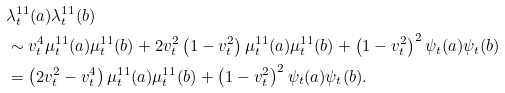<formula> <loc_0><loc_0><loc_500><loc_500>& \lambda ^ { 1 1 } _ { t } ( a ) \lambda ^ { 1 1 } _ { t } ( b ) \\ & \sim v _ { t } ^ { 4 } \mu ^ { 1 1 } _ { t } ( a ) \mu ^ { 1 1 } _ { t } ( b ) + 2 v _ { t } ^ { 2 } \left ( 1 - v _ { t } ^ { 2 } \right ) \mu ^ { 1 1 } _ { t } ( a ) \mu ^ { 1 1 } _ { t } ( b ) + \left ( 1 - v _ { t } ^ { 2 } \right ) ^ { 2 } \psi _ { t } ( a ) \psi _ { t } ( b ) \\ & = \left ( 2 v _ { t } ^ { 2 } - v _ { t } ^ { 4 } \right ) \mu ^ { 1 1 } _ { t } ( a ) \mu ^ { 1 1 } _ { t } ( b ) + \left ( 1 - v _ { t } ^ { 2 } \right ) ^ { 2 } \psi _ { t } ( a ) \psi _ { t } ( b ) .</formula> 